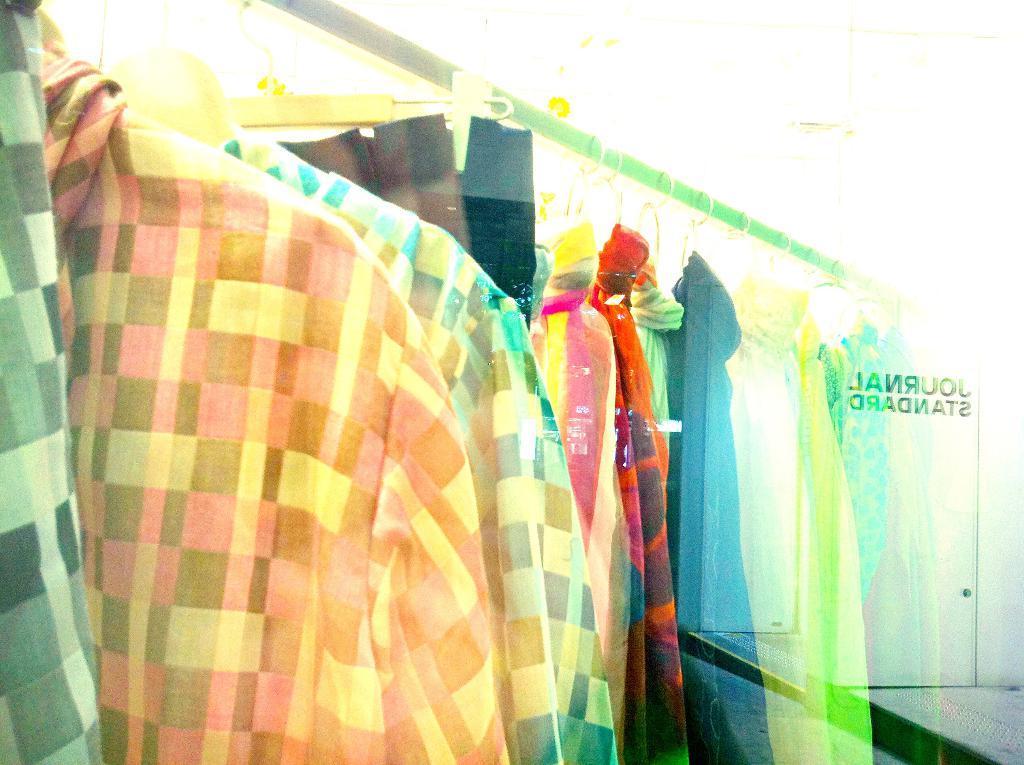Could you give a brief overview of what you see in this image? In the center of the image we can see shirts on the hangers. 